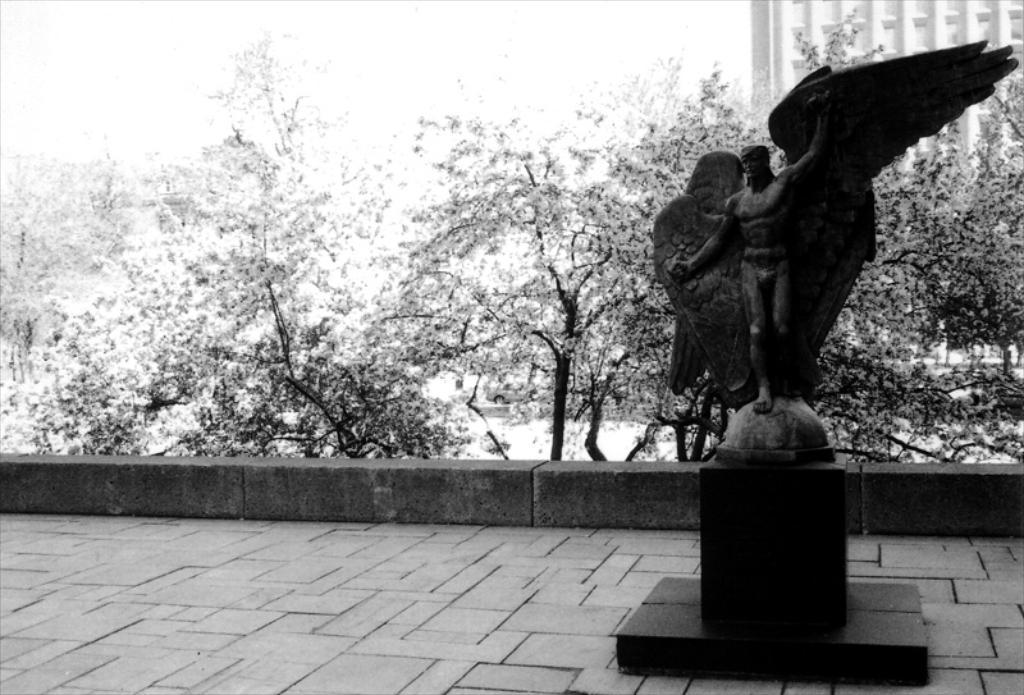Could you give a brief overview of what you see in this image? This is a black and white image. There is a statue on the right side. There are trees in the middle. There is payment in the bottom. There is a building on the right side. 